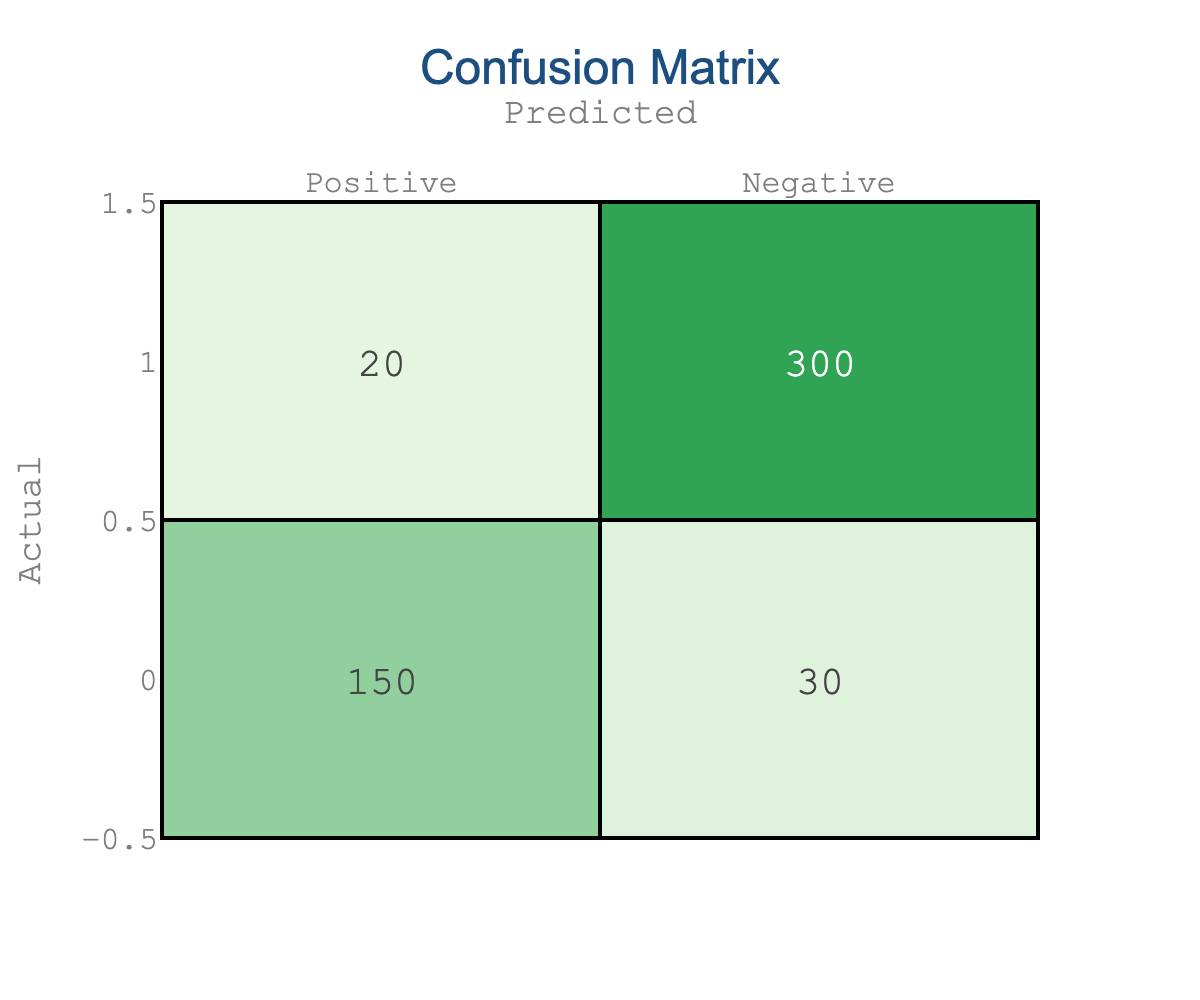What is the total number of true positive predictions? The true positives are located at the intersection of the actual positive and predicted positive categories. According to the table, there were 150 true positive predictions.
Answer: 150 What is the total number of false negative predictions? The false negatives represent the cases where the actual positive (150) was predicted as negative (20). Therefore, the number of false negatives is 20.
Answer: 20 How many true negative predictions were made? The true negatives are found at the intersection of the actual negative and predicted negative categories. The table shows that there were 300 true negative predictions.
Answer: 300 What is the overall accuracy of the model? The total number of correct predictions can be calculated as true positives (150) + true negatives (300) = 450. The total number of predictions is 150 + 30 + 20 + 300 = 500. Therefore, the accuracy is 450/500 = 0.90, or 90%.
Answer: 90% What is the precision of the model for positive predictions? Precision is calculated as the number of true positives divided by the total predicted positives. Here, precision = true positives / (true positives + false positives) = 150 / (150 + 30) = 150 / 180 = 0.833, which is about 83.3%.
Answer: 83.3% Is the number of true positives greater than the number of false positives? From the table, true positives are 150, while false positives are 30. Since 150 is greater than 30, the statement is true.
Answer: Yes Does the model have more false negatives than false positives? The table indicates false negatives are 20 and false positives are 30. Since 20 is less than 30, the model does not have more false negatives.
Answer: No If we combine true positives and true negatives, what percentage of the total predictions does that represent? The total of true positives (150) and true negatives (300) is 450. The total predictions is 500. Thus, the percentage is (450/500) * 100 = 90%.
Answer: 90% What is the difference between true negatives and false negatives? The number of true negatives is 300, while the number of false negatives is 20. The difference is 300 - 20 = 280.
Answer: 280 